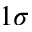<formula> <loc_0><loc_0><loc_500><loc_500>1 \sigma</formula> 